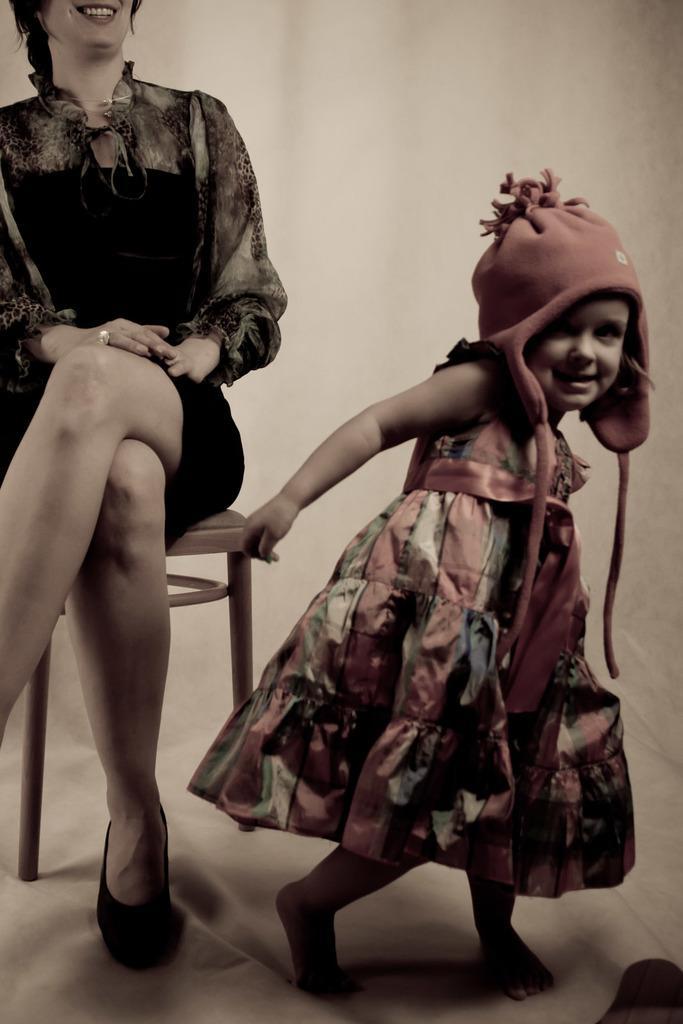In one or two sentences, can you explain what this image depicts? In this image we can see woman sitting on the chair and kid standing on the ground. In the background we can see wall. 